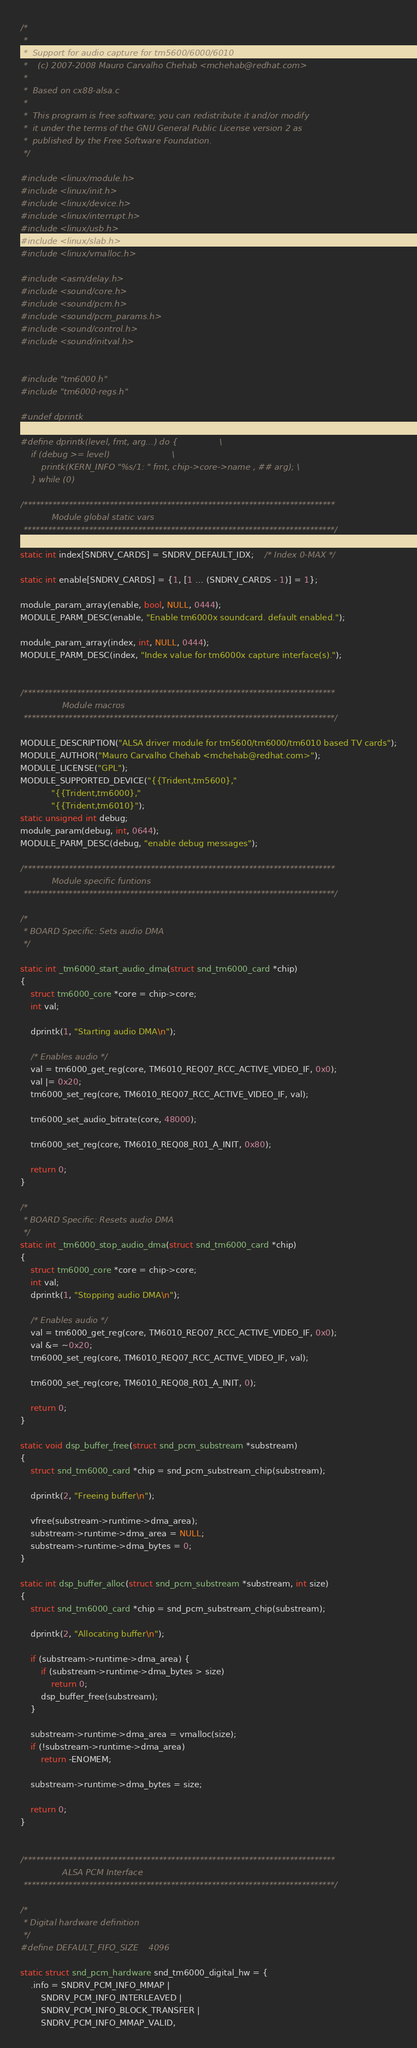<code> <loc_0><loc_0><loc_500><loc_500><_C_>/*
 *
 *  Support for audio capture for tm5600/6000/6010
 *    (c) 2007-2008 Mauro Carvalho Chehab <mchehab@redhat.com>
 *
 *  Based on cx88-alsa.c
 *
 *  This program is free software; you can redistribute it and/or modify
 *  it under the terms of the GNU General Public License version 2 as
 *  published by the Free Software Foundation.
 */

#include <linux/module.h>
#include <linux/init.h>
#include <linux/device.h>
#include <linux/interrupt.h>
#include <linux/usb.h>
#include <linux/slab.h>
#include <linux/vmalloc.h>

#include <asm/delay.h>
#include <sound/core.h>
#include <sound/pcm.h>
#include <sound/pcm_params.h>
#include <sound/control.h>
#include <sound/initval.h>


#include "tm6000.h"
#include "tm6000-regs.h"

#undef dprintk

#define dprintk(level, fmt, arg...) do {				   \
	if (debug >= level)						   \
		printk(KERN_INFO "%s/1: " fmt, chip->core->name , ## arg); \
	} while (0)

/****************************************************************************
			Module global static vars
 ****************************************************************************/

static int index[SNDRV_CARDS] = SNDRV_DEFAULT_IDX;	/* Index 0-MAX */

static int enable[SNDRV_CARDS] = {1, [1 ... (SNDRV_CARDS - 1)] = 1};

module_param_array(enable, bool, NULL, 0444);
MODULE_PARM_DESC(enable, "Enable tm6000x soundcard. default enabled.");

module_param_array(index, int, NULL, 0444);
MODULE_PARM_DESC(index, "Index value for tm6000x capture interface(s).");


/****************************************************************************
				Module macros
 ****************************************************************************/

MODULE_DESCRIPTION("ALSA driver module for tm5600/tm6000/tm6010 based TV cards");
MODULE_AUTHOR("Mauro Carvalho Chehab <mchehab@redhat.com>");
MODULE_LICENSE("GPL");
MODULE_SUPPORTED_DEVICE("{{Trident,tm5600},"
			"{{Trident,tm6000},"
			"{{Trident,tm6010}");
static unsigned int debug;
module_param(debug, int, 0644);
MODULE_PARM_DESC(debug, "enable debug messages");

/****************************************************************************
			Module specific funtions
 ****************************************************************************/

/*
 * BOARD Specific: Sets audio DMA
 */

static int _tm6000_start_audio_dma(struct snd_tm6000_card *chip)
{
	struct tm6000_core *core = chip->core;
	int val;

	dprintk(1, "Starting audio DMA\n");

	/* Enables audio */
	val = tm6000_get_reg(core, TM6010_REQ07_RCC_ACTIVE_VIDEO_IF, 0x0);
	val |= 0x20;
	tm6000_set_reg(core, TM6010_REQ07_RCC_ACTIVE_VIDEO_IF, val);

	tm6000_set_audio_bitrate(core, 48000);

	tm6000_set_reg(core, TM6010_REQ08_R01_A_INIT, 0x80);

	return 0;
}

/*
 * BOARD Specific: Resets audio DMA
 */
static int _tm6000_stop_audio_dma(struct snd_tm6000_card *chip)
{
	struct tm6000_core *core = chip->core;
	int val;
	dprintk(1, "Stopping audio DMA\n");

	/* Enables audio */
	val = tm6000_get_reg(core, TM6010_REQ07_RCC_ACTIVE_VIDEO_IF, 0x0);
	val &= ~0x20;
	tm6000_set_reg(core, TM6010_REQ07_RCC_ACTIVE_VIDEO_IF, val);

	tm6000_set_reg(core, TM6010_REQ08_R01_A_INIT, 0);

	return 0;
}

static void dsp_buffer_free(struct snd_pcm_substream *substream)
{
	struct snd_tm6000_card *chip = snd_pcm_substream_chip(substream);

	dprintk(2, "Freeing buffer\n");

	vfree(substream->runtime->dma_area);
	substream->runtime->dma_area = NULL;
	substream->runtime->dma_bytes = 0;
}

static int dsp_buffer_alloc(struct snd_pcm_substream *substream, int size)
{
	struct snd_tm6000_card *chip = snd_pcm_substream_chip(substream);

	dprintk(2, "Allocating buffer\n");

	if (substream->runtime->dma_area) {
		if (substream->runtime->dma_bytes > size)
			return 0;
		dsp_buffer_free(substream);
	}

	substream->runtime->dma_area = vmalloc(size);
	if (!substream->runtime->dma_area)
		return -ENOMEM;

	substream->runtime->dma_bytes = size;

	return 0;
}


/****************************************************************************
				ALSA PCM Interface
 ****************************************************************************/

/*
 * Digital hardware definition
 */
#define DEFAULT_FIFO_SIZE	4096

static struct snd_pcm_hardware snd_tm6000_digital_hw = {
	.info = SNDRV_PCM_INFO_MMAP |
		SNDRV_PCM_INFO_INTERLEAVED |
		SNDRV_PCM_INFO_BLOCK_TRANSFER |
		SNDRV_PCM_INFO_MMAP_VALID,</code> 